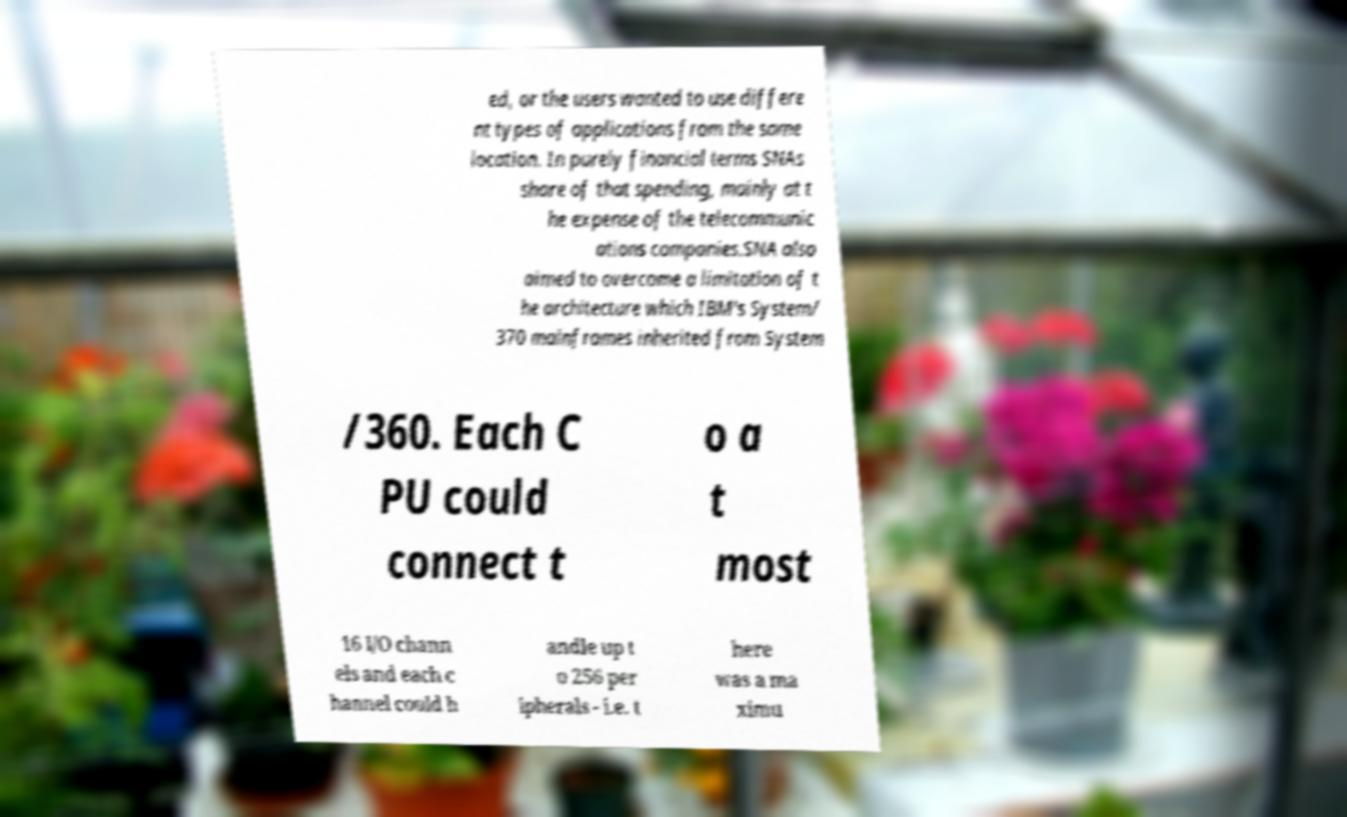Please identify and transcribe the text found in this image. ed, or the users wanted to use differe nt types of applications from the same location. In purely financial terms SNAs share of that spending, mainly at t he expense of the telecommunic ations companies.SNA also aimed to overcome a limitation of t he architecture which IBM's System/ 370 mainframes inherited from System /360. Each C PU could connect t o a t most 16 I/O chann els and each c hannel could h andle up t o 256 per ipherals - i.e. t here was a ma ximu 